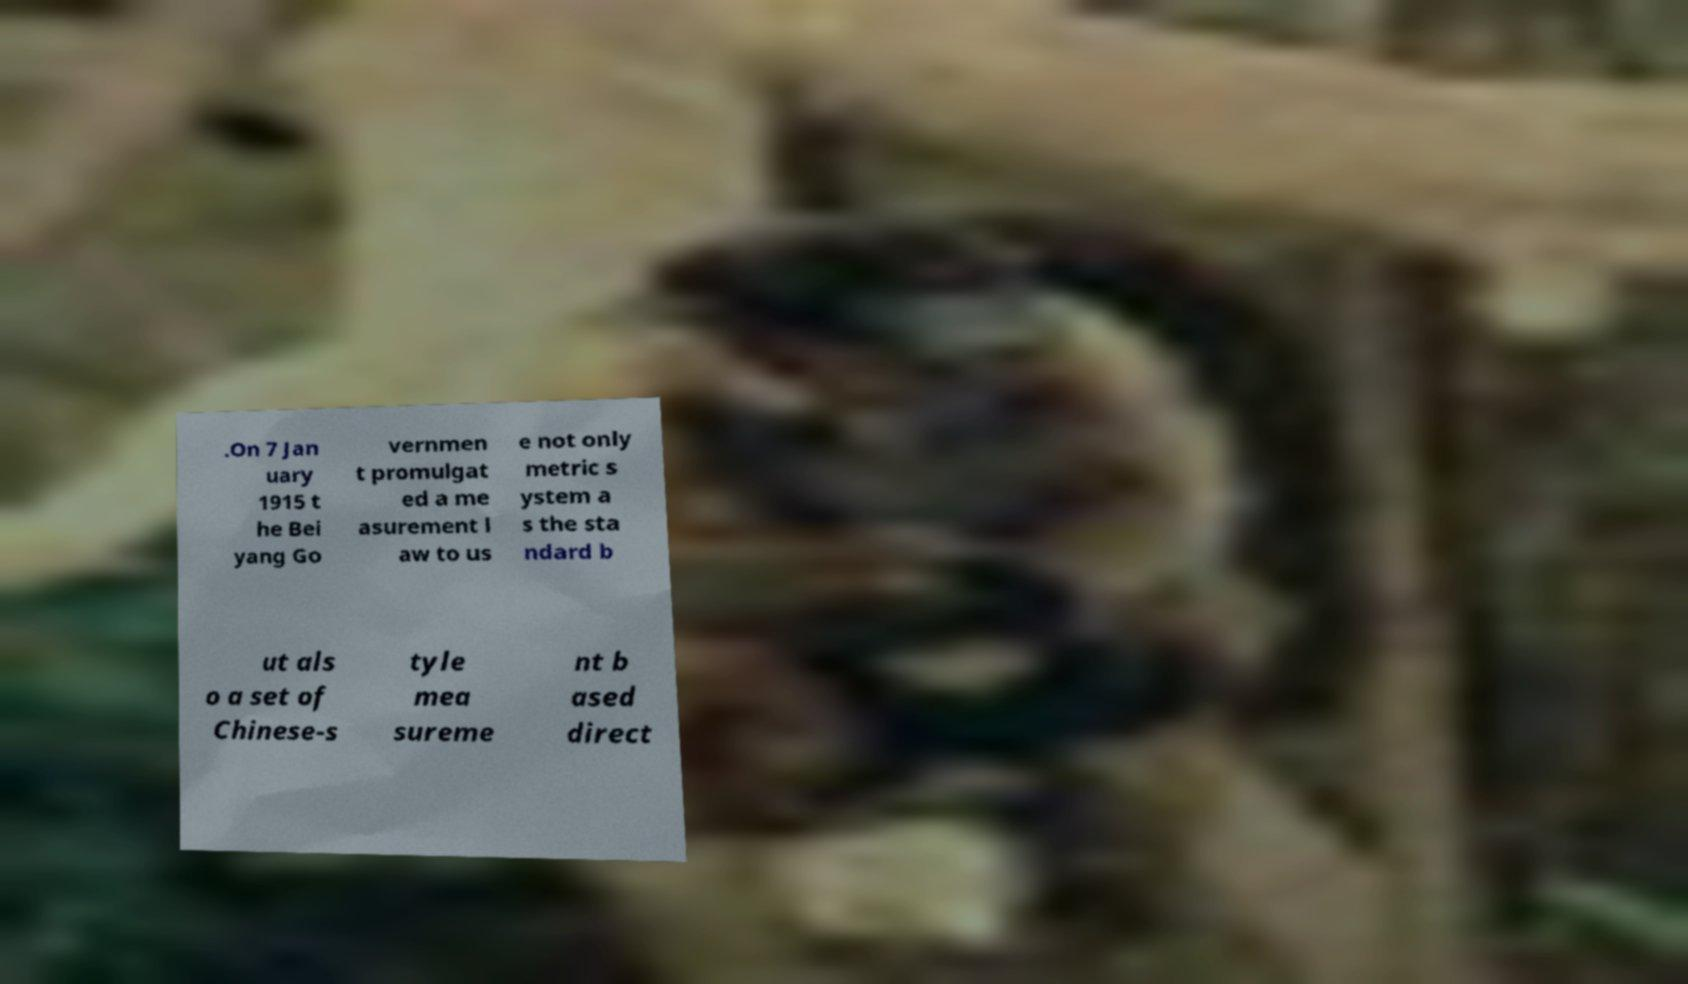Can you accurately transcribe the text from the provided image for me? .On 7 Jan uary 1915 t he Bei yang Go vernmen t promulgat ed a me asurement l aw to us e not only metric s ystem a s the sta ndard b ut als o a set of Chinese-s tyle mea sureme nt b ased direct 